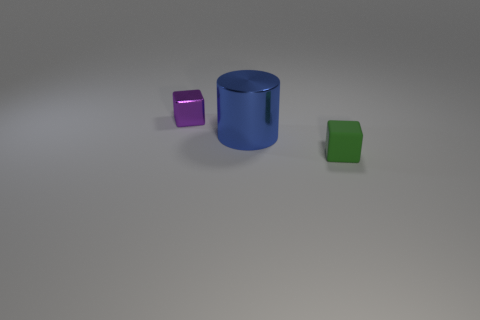Add 3 large blue cylinders. How many objects exist? 6 Subtract all cubes. How many objects are left? 1 Subtract 0 red blocks. How many objects are left? 3 Subtract 1 cylinders. How many cylinders are left? 0 Subtract all cyan blocks. Subtract all green spheres. How many blocks are left? 2 Subtract all green cylinders. How many blue blocks are left? 0 Subtract all purple metallic things. Subtract all tiny green cubes. How many objects are left? 1 Add 1 blue metallic cylinders. How many blue metallic cylinders are left? 2 Add 1 big matte spheres. How many big matte spheres exist? 1 